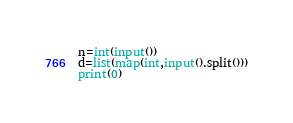<code> <loc_0><loc_0><loc_500><loc_500><_Python_>n=int(input())
d=list(map(int,input().split()))
print(0)</code> 